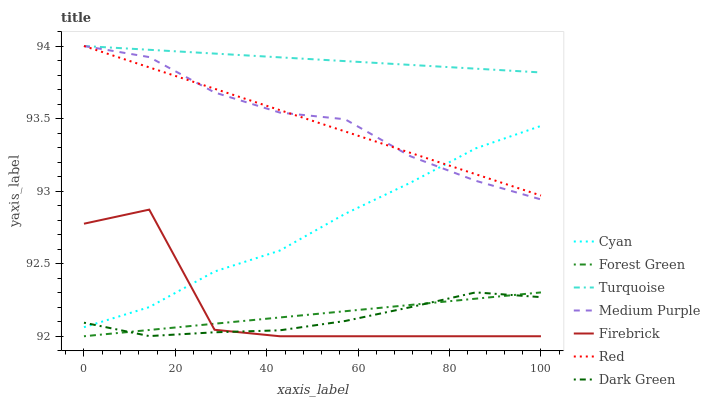Does Dark Green have the minimum area under the curve?
Answer yes or no. Yes. Does Turquoise have the maximum area under the curve?
Answer yes or no. Yes. Does Firebrick have the minimum area under the curve?
Answer yes or no. No. Does Firebrick have the maximum area under the curve?
Answer yes or no. No. Is Turquoise the smoothest?
Answer yes or no. Yes. Is Firebrick the roughest?
Answer yes or no. Yes. Is Medium Purple the smoothest?
Answer yes or no. No. Is Medium Purple the roughest?
Answer yes or no. No. Does Medium Purple have the lowest value?
Answer yes or no. No. Does Firebrick have the highest value?
Answer yes or no. No. Is Dark Green less than Medium Purple?
Answer yes or no. Yes. Is Red greater than Forest Green?
Answer yes or no. Yes. Does Dark Green intersect Medium Purple?
Answer yes or no. No. 